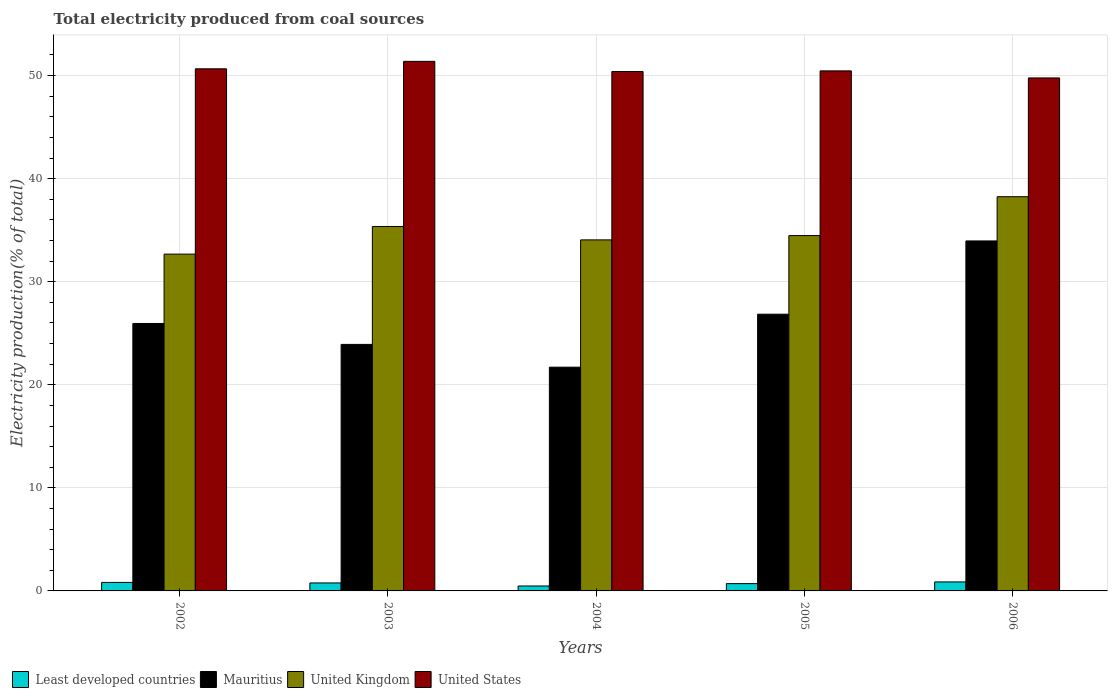How many groups of bars are there?
Give a very brief answer. 5. Are the number of bars per tick equal to the number of legend labels?
Ensure brevity in your answer.  Yes. How many bars are there on the 4th tick from the right?
Your answer should be very brief. 4. What is the total electricity produced in United States in 2003?
Your answer should be compact. 51.38. Across all years, what is the maximum total electricity produced in Mauritius?
Offer a very short reply. 33.96. Across all years, what is the minimum total electricity produced in Least developed countries?
Offer a very short reply. 0.48. In which year was the total electricity produced in Mauritius maximum?
Ensure brevity in your answer.  2006. What is the total total electricity produced in United States in the graph?
Your response must be concise. 252.67. What is the difference between the total electricity produced in United Kingdom in 2003 and that in 2004?
Give a very brief answer. 1.3. What is the difference between the total electricity produced in United Kingdom in 2005 and the total electricity produced in United States in 2006?
Ensure brevity in your answer.  -15.29. What is the average total electricity produced in Mauritius per year?
Give a very brief answer. 26.48. In the year 2002, what is the difference between the total electricity produced in United Kingdom and total electricity produced in Mauritius?
Ensure brevity in your answer.  6.73. In how many years, is the total electricity produced in Least developed countries greater than 28 %?
Ensure brevity in your answer.  0. What is the ratio of the total electricity produced in Mauritius in 2005 to that in 2006?
Give a very brief answer. 0.79. Is the total electricity produced in Least developed countries in 2004 less than that in 2006?
Provide a short and direct response. Yes. What is the difference between the highest and the second highest total electricity produced in United Kingdom?
Provide a short and direct response. 2.89. What is the difference between the highest and the lowest total electricity produced in United Kingdom?
Keep it short and to the point. 5.57. In how many years, is the total electricity produced in Mauritius greater than the average total electricity produced in Mauritius taken over all years?
Provide a succinct answer. 2. Is the sum of the total electricity produced in United States in 2002 and 2005 greater than the maximum total electricity produced in Least developed countries across all years?
Offer a very short reply. Yes. Is it the case that in every year, the sum of the total electricity produced in United States and total electricity produced in Mauritius is greater than the sum of total electricity produced in United Kingdom and total electricity produced in Least developed countries?
Your answer should be compact. Yes. What does the 2nd bar from the left in 2006 represents?
Your answer should be very brief. Mauritius. What does the 3rd bar from the right in 2002 represents?
Ensure brevity in your answer.  Mauritius. How many bars are there?
Your response must be concise. 20. Are all the bars in the graph horizontal?
Your answer should be very brief. No. Does the graph contain any zero values?
Your response must be concise. No. How are the legend labels stacked?
Provide a succinct answer. Horizontal. What is the title of the graph?
Provide a short and direct response. Total electricity produced from coal sources. What is the Electricity production(% of total) in Least developed countries in 2002?
Make the answer very short. 0.83. What is the Electricity production(% of total) in Mauritius in 2002?
Provide a succinct answer. 25.95. What is the Electricity production(% of total) of United Kingdom in 2002?
Your answer should be very brief. 32.68. What is the Electricity production(% of total) in United States in 2002?
Provide a succinct answer. 50.66. What is the Electricity production(% of total) in Least developed countries in 2003?
Ensure brevity in your answer.  0.77. What is the Electricity production(% of total) in Mauritius in 2003?
Ensure brevity in your answer.  23.92. What is the Electricity production(% of total) in United Kingdom in 2003?
Your answer should be very brief. 35.36. What is the Electricity production(% of total) in United States in 2003?
Keep it short and to the point. 51.38. What is the Electricity production(% of total) in Least developed countries in 2004?
Offer a terse response. 0.48. What is the Electricity production(% of total) in Mauritius in 2004?
Keep it short and to the point. 21.71. What is the Electricity production(% of total) of United Kingdom in 2004?
Make the answer very short. 34.06. What is the Electricity production(% of total) in United States in 2004?
Keep it short and to the point. 50.4. What is the Electricity production(% of total) in Least developed countries in 2005?
Offer a very short reply. 0.71. What is the Electricity production(% of total) of Mauritius in 2005?
Your response must be concise. 26.85. What is the Electricity production(% of total) in United Kingdom in 2005?
Give a very brief answer. 34.48. What is the Electricity production(% of total) in United States in 2005?
Make the answer very short. 50.46. What is the Electricity production(% of total) of Least developed countries in 2006?
Ensure brevity in your answer.  0.87. What is the Electricity production(% of total) of Mauritius in 2006?
Your response must be concise. 33.96. What is the Electricity production(% of total) of United Kingdom in 2006?
Your response must be concise. 38.25. What is the Electricity production(% of total) of United States in 2006?
Your response must be concise. 49.77. Across all years, what is the maximum Electricity production(% of total) in Least developed countries?
Give a very brief answer. 0.87. Across all years, what is the maximum Electricity production(% of total) of Mauritius?
Offer a terse response. 33.96. Across all years, what is the maximum Electricity production(% of total) in United Kingdom?
Keep it short and to the point. 38.25. Across all years, what is the maximum Electricity production(% of total) in United States?
Your response must be concise. 51.38. Across all years, what is the minimum Electricity production(% of total) in Least developed countries?
Your response must be concise. 0.48. Across all years, what is the minimum Electricity production(% of total) of Mauritius?
Provide a short and direct response. 21.71. Across all years, what is the minimum Electricity production(% of total) in United Kingdom?
Offer a very short reply. 32.68. Across all years, what is the minimum Electricity production(% of total) of United States?
Your answer should be compact. 49.77. What is the total Electricity production(% of total) in Least developed countries in the graph?
Offer a terse response. 3.66. What is the total Electricity production(% of total) of Mauritius in the graph?
Offer a terse response. 132.38. What is the total Electricity production(% of total) of United Kingdom in the graph?
Your response must be concise. 174.82. What is the total Electricity production(% of total) of United States in the graph?
Make the answer very short. 252.67. What is the difference between the Electricity production(% of total) in Least developed countries in 2002 and that in 2003?
Your answer should be compact. 0.05. What is the difference between the Electricity production(% of total) of Mauritius in 2002 and that in 2003?
Ensure brevity in your answer.  2.03. What is the difference between the Electricity production(% of total) in United Kingdom in 2002 and that in 2003?
Keep it short and to the point. -2.68. What is the difference between the Electricity production(% of total) in United States in 2002 and that in 2003?
Ensure brevity in your answer.  -0.72. What is the difference between the Electricity production(% of total) of Least developed countries in 2002 and that in 2004?
Keep it short and to the point. 0.35. What is the difference between the Electricity production(% of total) of Mauritius in 2002 and that in 2004?
Keep it short and to the point. 4.24. What is the difference between the Electricity production(% of total) of United Kingdom in 2002 and that in 2004?
Offer a very short reply. -1.38. What is the difference between the Electricity production(% of total) in United States in 2002 and that in 2004?
Ensure brevity in your answer.  0.26. What is the difference between the Electricity production(% of total) of Least developed countries in 2002 and that in 2005?
Your answer should be very brief. 0.12. What is the difference between the Electricity production(% of total) in Mauritius in 2002 and that in 2005?
Provide a short and direct response. -0.9. What is the difference between the Electricity production(% of total) in United Kingdom in 2002 and that in 2005?
Your answer should be compact. -1.8. What is the difference between the Electricity production(% of total) in United States in 2002 and that in 2005?
Give a very brief answer. 0.2. What is the difference between the Electricity production(% of total) in Least developed countries in 2002 and that in 2006?
Offer a very short reply. -0.05. What is the difference between the Electricity production(% of total) in Mauritius in 2002 and that in 2006?
Give a very brief answer. -8.01. What is the difference between the Electricity production(% of total) in United Kingdom in 2002 and that in 2006?
Your answer should be compact. -5.57. What is the difference between the Electricity production(% of total) of United States in 2002 and that in 2006?
Give a very brief answer. 0.88. What is the difference between the Electricity production(% of total) in Least developed countries in 2003 and that in 2004?
Offer a very short reply. 0.3. What is the difference between the Electricity production(% of total) in Mauritius in 2003 and that in 2004?
Provide a short and direct response. 2.21. What is the difference between the Electricity production(% of total) in United Kingdom in 2003 and that in 2004?
Provide a succinct answer. 1.3. What is the difference between the Electricity production(% of total) of United States in 2003 and that in 2004?
Provide a short and direct response. 0.98. What is the difference between the Electricity production(% of total) of Least developed countries in 2003 and that in 2005?
Give a very brief answer. 0.07. What is the difference between the Electricity production(% of total) of Mauritius in 2003 and that in 2005?
Make the answer very short. -2.93. What is the difference between the Electricity production(% of total) in United Kingdom in 2003 and that in 2005?
Provide a succinct answer. 0.88. What is the difference between the Electricity production(% of total) in United States in 2003 and that in 2005?
Your answer should be compact. 0.92. What is the difference between the Electricity production(% of total) of Least developed countries in 2003 and that in 2006?
Your answer should be very brief. -0.1. What is the difference between the Electricity production(% of total) of Mauritius in 2003 and that in 2006?
Provide a short and direct response. -10.04. What is the difference between the Electricity production(% of total) in United Kingdom in 2003 and that in 2006?
Ensure brevity in your answer.  -2.89. What is the difference between the Electricity production(% of total) in United States in 2003 and that in 2006?
Offer a very short reply. 1.61. What is the difference between the Electricity production(% of total) of Least developed countries in 2004 and that in 2005?
Make the answer very short. -0.23. What is the difference between the Electricity production(% of total) in Mauritius in 2004 and that in 2005?
Keep it short and to the point. -5.14. What is the difference between the Electricity production(% of total) of United Kingdom in 2004 and that in 2005?
Ensure brevity in your answer.  -0.42. What is the difference between the Electricity production(% of total) of United States in 2004 and that in 2005?
Your answer should be compact. -0.06. What is the difference between the Electricity production(% of total) in Least developed countries in 2004 and that in 2006?
Your answer should be very brief. -0.39. What is the difference between the Electricity production(% of total) in Mauritius in 2004 and that in 2006?
Make the answer very short. -12.25. What is the difference between the Electricity production(% of total) of United Kingdom in 2004 and that in 2006?
Offer a very short reply. -4.19. What is the difference between the Electricity production(% of total) of United States in 2004 and that in 2006?
Provide a short and direct response. 0.62. What is the difference between the Electricity production(% of total) in Least developed countries in 2005 and that in 2006?
Offer a terse response. -0.16. What is the difference between the Electricity production(% of total) of Mauritius in 2005 and that in 2006?
Provide a short and direct response. -7.11. What is the difference between the Electricity production(% of total) of United Kingdom in 2005 and that in 2006?
Offer a terse response. -3.77. What is the difference between the Electricity production(% of total) of United States in 2005 and that in 2006?
Give a very brief answer. 0.68. What is the difference between the Electricity production(% of total) in Least developed countries in 2002 and the Electricity production(% of total) in Mauritius in 2003?
Give a very brief answer. -23.09. What is the difference between the Electricity production(% of total) of Least developed countries in 2002 and the Electricity production(% of total) of United Kingdom in 2003?
Offer a terse response. -34.53. What is the difference between the Electricity production(% of total) in Least developed countries in 2002 and the Electricity production(% of total) in United States in 2003?
Keep it short and to the point. -50.56. What is the difference between the Electricity production(% of total) of Mauritius in 2002 and the Electricity production(% of total) of United Kingdom in 2003?
Your answer should be compact. -9.41. What is the difference between the Electricity production(% of total) of Mauritius in 2002 and the Electricity production(% of total) of United States in 2003?
Offer a very short reply. -25.43. What is the difference between the Electricity production(% of total) of United Kingdom in 2002 and the Electricity production(% of total) of United States in 2003?
Make the answer very short. -18.7. What is the difference between the Electricity production(% of total) of Least developed countries in 2002 and the Electricity production(% of total) of Mauritius in 2004?
Ensure brevity in your answer.  -20.88. What is the difference between the Electricity production(% of total) of Least developed countries in 2002 and the Electricity production(% of total) of United Kingdom in 2004?
Provide a succinct answer. -33.23. What is the difference between the Electricity production(% of total) of Least developed countries in 2002 and the Electricity production(% of total) of United States in 2004?
Offer a terse response. -49.57. What is the difference between the Electricity production(% of total) in Mauritius in 2002 and the Electricity production(% of total) in United Kingdom in 2004?
Offer a very short reply. -8.11. What is the difference between the Electricity production(% of total) of Mauritius in 2002 and the Electricity production(% of total) of United States in 2004?
Make the answer very short. -24.45. What is the difference between the Electricity production(% of total) in United Kingdom in 2002 and the Electricity production(% of total) in United States in 2004?
Offer a terse response. -17.72. What is the difference between the Electricity production(% of total) in Least developed countries in 2002 and the Electricity production(% of total) in Mauritius in 2005?
Your answer should be very brief. -26.02. What is the difference between the Electricity production(% of total) in Least developed countries in 2002 and the Electricity production(% of total) in United Kingdom in 2005?
Your response must be concise. -33.65. What is the difference between the Electricity production(% of total) in Least developed countries in 2002 and the Electricity production(% of total) in United States in 2005?
Ensure brevity in your answer.  -49.63. What is the difference between the Electricity production(% of total) of Mauritius in 2002 and the Electricity production(% of total) of United Kingdom in 2005?
Offer a very short reply. -8.53. What is the difference between the Electricity production(% of total) in Mauritius in 2002 and the Electricity production(% of total) in United States in 2005?
Make the answer very short. -24.51. What is the difference between the Electricity production(% of total) in United Kingdom in 2002 and the Electricity production(% of total) in United States in 2005?
Ensure brevity in your answer.  -17.78. What is the difference between the Electricity production(% of total) in Least developed countries in 2002 and the Electricity production(% of total) in Mauritius in 2006?
Offer a very short reply. -33.13. What is the difference between the Electricity production(% of total) of Least developed countries in 2002 and the Electricity production(% of total) of United Kingdom in 2006?
Give a very brief answer. -37.42. What is the difference between the Electricity production(% of total) of Least developed countries in 2002 and the Electricity production(% of total) of United States in 2006?
Offer a terse response. -48.95. What is the difference between the Electricity production(% of total) of Mauritius in 2002 and the Electricity production(% of total) of United Kingdom in 2006?
Make the answer very short. -12.3. What is the difference between the Electricity production(% of total) of Mauritius in 2002 and the Electricity production(% of total) of United States in 2006?
Your answer should be compact. -23.82. What is the difference between the Electricity production(% of total) of United Kingdom in 2002 and the Electricity production(% of total) of United States in 2006?
Give a very brief answer. -17.09. What is the difference between the Electricity production(% of total) in Least developed countries in 2003 and the Electricity production(% of total) in Mauritius in 2004?
Your response must be concise. -20.94. What is the difference between the Electricity production(% of total) of Least developed countries in 2003 and the Electricity production(% of total) of United Kingdom in 2004?
Give a very brief answer. -33.29. What is the difference between the Electricity production(% of total) of Least developed countries in 2003 and the Electricity production(% of total) of United States in 2004?
Keep it short and to the point. -49.62. What is the difference between the Electricity production(% of total) of Mauritius in 2003 and the Electricity production(% of total) of United Kingdom in 2004?
Provide a succinct answer. -10.14. What is the difference between the Electricity production(% of total) in Mauritius in 2003 and the Electricity production(% of total) in United States in 2004?
Keep it short and to the point. -26.48. What is the difference between the Electricity production(% of total) of United Kingdom in 2003 and the Electricity production(% of total) of United States in 2004?
Your answer should be compact. -15.04. What is the difference between the Electricity production(% of total) in Least developed countries in 2003 and the Electricity production(% of total) in Mauritius in 2005?
Offer a terse response. -26.08. What is the difference between the Electricity production(% of total) of Least developed countries in 2003 and the Electricity production(% of total) of United Kingdom in 2005?
Offer a very short reply. -33.7. What is the difference between the Electricity production(% of total) of Least developed countries in 2003 and the Electricity production(% of total) of United States in 2005?
Provide a succinct answer. -49.68. What is the difference between the Electricity production(% of total) of Mauritius in 2003 and the Electricity production(% of total) of United Kingdom in 2005?
Your answer should be compact. -10.56. What is the difference between the Electricity production(% of total) in Mauritius in 2003 and the Electricity production(% of total) in United States in 2005?
Your answer should be very brief. -26.54. What is the difference between the Electricity production(% of total) of United Kingdom in 2003 and the Electricity production(% of total) of United States in 2005?
Give a very brief answer. -15.1. What is the difference between the Electricity production(% of total) in Least developed countries in 2003 and the Electricity production(% of total) in Mauritius in 2006?
Offer a very short reply. -33.18. What is the difference between the Electricity production(% of total) of Least developed countries in 2003 and the Electricity production(% of total) of United Kingdom in 2006?
Your answer should be compact. -37.47. What is the difference between the Electricity production(% of total) of Least developed countries in 2003 and the Electricity production(% of total) of United States in 2006?
Provide a short and direct response. -49. What is the difference between the Electricity production(% of total) of Mauritius in 2003 and the Electricity production(% of total) of United Kingdom in 2006?
Offer a terse response. -14.33. What is the difference between the Electricity production(% of total) in Mauritius in 2003 and the Electricity production(% of total) in United States in 2006?
Offer a very short reply. -25.85. What is the difference between the Electricity production(% of total) of United Kingdom in 2003 and the Electricity production(% of total) of United States in 2006?
Provide a short and direct response. -14.41. What is the difference between the Electricity production(% of total) of Least developed countries in 2004 and the Electricity production(% of total) of Mauritius in 2005?
Ensure brevity in your answer.  -26.37. What is the difference between the Electricity production(% of total) of Least developed countries in 2004 and the Electricity production(% of total) of United Kingdom in 2005?
Offer a very short reply. -34. What is the difference between the Electricity production(% of total) of Least developed countries in 2004 and the Electricity production(% of total) of United States in 2005?
Offer a terse response. -49.98. What is the difference between the Electricity production(% of total) in Mauritius in 2004 and the Electricity production(% of total) in United Kingdom in 2005?
Your answer should be very brief. -12.77. What is the difference between the Electricity production(% of total) in Mauritius in 2004 and the Electricity production(% of total) in United States in 2005?
Your answer should be compact. -28.75. What is the difference between the Electricity production(% of total) of United Kingdom in 2004 and the Electricity production(% of total) of United States in 2005?
Keep it short and to the point. -16.4. What is the difference between the Electricity production(% of total) in Least developed countries in 2004 and the Electricity production(% of total) in Mauritius in 2006?
Your answer should be very brief. -33.48. What is the difference between the Electricity production(% of total) of Least developed countries in 2004 and the Electricity production(% of total) of United Kingdom in 2006?
Provide a short and direct response. -37.77. What is the difference between the Electricity production(% of total) in Least developed countries in 2004 and the Electricity production(% of total) in United States in 2006?
Offer a terse response. -49.3. What is the difference between the Electricity production(% of total) in Mauritius in 2004 and the Electricity production(% of total) in United Kingdom in 2006?
Provide a short and direct response. -16.54. What is the difference between the Electricity production(% of total) of Mauritius in 2004 and the Electricity production(% of total) of United States in 2006?
Give a very brief answer. -28.06. What is the difference between the Electricity production(% of total) of United Kingdom in 2004 and the Electricity production(% of total) of United States in 2006?
Keep it short and to the point. -15.71. What is the difference between the Electricity production(% of total) of Least developed countries in 2005 and the Electricity production(% of total) of Mauritius in 2006?
Your answer should be very brief. -33.25. What is the difference between the Electricity production(% of total) of Least developed countries in 2005 and the Electricity production(% of total) of United Kingdom in 2006?
Offer a terse response. -37.54. What is the difference between the Electricity production(% of total) in Least developed countries in 2005 and the Electricity production(% of total) in United States in 2006?
Your answer should be compact. -49.07. What is the difference between the Electricity production(% of total) of Mauritius in 2005 and the Electricity production(% of total) of United Kingdom in 2006?
Keep it short and to the point. -11.4. What is the difference between the Electricity production(% of total) of Mauritius in 2005 and the Electricity production(% of total) of United States in 2006?
Ensure brevity in your answer.  -22.92. What is the difference between the Electricity production(% of total) in United Kingdom in 2005 and the Electricity production(% of total) in United States in 2006?
Provide a short and direct response. -15.29. What is the average Electricity production(% of total) of Least developed countries per year?
Provide a short and direct response. 0.73. What is the average Electricity production(% of total) in Mauritius per year?
Offer a terse response. 26.48. What is the average Electricity production(% of total) of United Kingdom per year?
Give a very brief answer. 34.97. What is the average Electricity production(% of total) of United States per year?
Provide a short and direct response. 50.53. In the year 2002, what is the difference between the Electricity production(% of total) of Least developed countries and Electricity production(% of total) of Mauritius?
Provide a short and direct response. -25.12. In the year 2002, what is the difference between the Electricity production(% of total) of Least developed countries and Electricity production(% of total) of United Kingdom?
Provide a succinct answer. -31.85. In the year 2002, what is the difference between the Electricity production(% of total) of Least developed countries and Electricity production(% of total) of United States?
Offer a terse response. -49.83. In the year 2002, what is the difference between the Electricity production(% of total) of Mauritius and Electricity production(% of total) of United Kingdom?
Your answer should be very brief. -6.73. In the year 2002, what is the difference between the Electricity production(% of total) of Mauritius and Electricity production(% of total) of United States?
Provide a succinct answer. -24.71. In the year 2002, what is the difference between the Electricity production(% of total) in United Kingdom and Electricity production(% of total) in United States?
Give a very brief answer. -17.98. In the year 2003, what is the difference between the Electricity production(% of total) in Least developed countries and Electricity production(% of total) in Mauritius?
Offer a terse response. -23.15. In the year 2003, what is the difference between the Electricity production(% of total) in Least developed countries and Electricity production(% of total) in United Kingdom?
Make the answer very short. -34.59. In the year 2003, what is the difference between the Electricity production(% of total) of Least developed countries and Electricity production(% of total) of United States?
Your response must be concise. -50.61. In the year 2003, what is the difference between the Electricity production(% of total) in Mauritius and Electricity production(% of total) in United Kingdom?
Provide a short and direct response. -11.44. In the year 2003, what is the difference between the Electricity production(% of total) of Mauritius and Electricity production(% of total) of United States?
Offer a very short reply. -27.46. In the year 2003, what is the difference between the Electricity production(% of total) of United Kingdom and Electricity production(% of total) of United States?
Give a very brief answer. -16.02. In the year 2004, what is the difference between the Electricity production(% of total) of Least developed countries and Electricity production(% of total) of Mauritius?
Your response must be concise. -21.23. In the year 2004, what is the difference between the Electricity production(% of total) of Least developed countries and Electricity production(% of total) of United Kingdom?
Your response must be concise. -33.58. In the year 2004, what is the difference between the Electricity production(% of total) in Least developed countries and Electricity production(% of total) in United States?
Give a very brief answer. -49.92. In the year 2004, what is the difference between the Electricity production(% of total) in Mauritius and Electricity production(% of total) in United Kingdom?
Make the answer very short. -12.35. In the year 2004, what is the difference between the Electricity production(% of total) in Mauritius and Electricity production(% of total) in United States?
Provide a short and direct response. -28.69. In the year 2004, what is the difference between the Electricity production(% of total) in United Kingdom and Electricity production(% of total) in United States?
Give a very brief answer. -16.34. In the year 2005, what is the difference between the Electricity production(% of total) in Least developed countries and Electricity production(% of total) in Mauritius?
Your answer should be very brief. -26.14. In the year 2005, what is the difference between the Electricity production(% of total) in Least developed countries and Electricity production(% of total) in United Kingdom?
Offer a very short reply. -33.77. In the year 2005, what is the difference between the Electricity production(% of total) in Least developed countries and Electricity production(% of total) in United States?
Ensure brevity in your answer.  -49.75. In the year 2005, what is the difference between the Electricity production(% of total) in Mauritius and Electricity production(% of total) in United Kingdom?
Offer a very short reply. -7.63. In the year 2005, what is the difference between the Electricity production(% of total) of Mauritius and Electricity production(% of total) of United States?
Your response must be concise. -23.61. In the year 2005, what is the difference between the Electricity production(% of total) of United Kingdom and Electricity production(% of total) of United States?
Ensure brevity in your answer.  -15.98. In the year 2006, what is the difference between the Electricity production(% of total) in Least developed countries and Electricity production(% of total) in Mauritius?
Offer a terse response. -33.09. In the year 2006, what is the difference between the Electricity production(% of total) of Least developed countries and Electricity production(% of total) of United Kingdom?
Offer a terse response. -37.38. In the year 2006, what is the difference between the Electricity production(% of total) in Least developed countries and Electricity production(% of total) in United States?
Your answer should be very brief. -48.9. In the year 2006, what is the difference between the Electricity production(% of total) of Mauritius and Electricity production(% of total) of United Kingdom?
Make the answer very short. -4.29. In the year 2006, what is the difference between the Electricity production(% of total) of Mauritius and Electricity production(% of total) of United States?
Offer a very short reply. -15.82. In the year 2006, what is the difference between the Electricity production(% of total) in United Kingdom and Electricity production(% of total) in United States?
Offer a very short reply. -11.52. What is the ratio of the Electricity production(% of total) in Least developed countries in 2002 to that in 2003?
Offer a very short reply. 1.07. What is the ratio of the Electricity production(% of total) in Mauritius in 2002 to that in 2003?
Offer a very short reply. 1.08. What is the ratio of the Electricity production(% of total) of United Kingdom in 2002 to that in 2003?
Offer a very short reply. 0.92. What is the ratio of the Electricity production(% of total) in United States in 2002 to that in 2003?
Provide a succinct answer. 0.99. What is the ratio of the Electricity production(% of total) of Least developed countries in 2002 to that in 2004?
Provide a short and direct response. 1.73. What is the ratio of the Electricity production(% of total) of Mauritius in 2002 to that in 2004?
Your response must be concise. 1.2. What is the ratio of the Electricity production(% of total) in United Kingdom in 2002 to that in 2004?
Give a very brief answer. 0.96. What is the ratio of the Electricity production(% of total) of United States in 2002 to that in 2004?
Offer a very short reply. 1.01. What is the ratio of the Electricity production(% of total) of Least developed countries in 2002 to that in 2005?
Offer a very short reply. 1.17. What is the ratio of the Electricity production(% of total) in Mauritius in 2002 to that in 2005?
Your answer should be compact. 0.97. What is the ratio of the Electricity production(% of total) in United Kingdom in 2002 to that in 2005?
Keep it short and to the point. 0.95. What is the ratio of the Electricity production(% of total) in United States in 2002 to that in 2005?
Your answer should be very brief. 1. What is the ratio of the Electricity production(% of total) in Least developed countries in 2002 to that in 2006?
Offer a terse response. 0.95. What is the ratio of the Electricity production(% of total) of Mauritius in 2002 to that in 2006?
Ensure brevity in your answer.  0.76. What is the ratio of the Electricity production(% of total) of United Kingdom in 2002 to that in 2006?
Give a very brief answer. 0.85. What is the ratio of the Electricity production(% of total) in United States in 2002 to that in 2006?
Make the answer very short. 1.02. What is the ratio of the Electricity production(% of total) of Least developed countries in 2003 to that in 2004?
Offer a terse response. 1.62. What is the ratio of the Electricity production(% of total) of Mauritius in 2003 to that in 2004?
Provide a succinct answer. 1.1. What is the ratio of the Electricity production(% of total) in United Kingdom in 2003 to that in 2004?
Your answer should be compact. 1.04. What is the ratio of the Electricity production(% of total) of United States in 2003 to that in 2004?
Offer a terse response. 1.02. What is the ratio of the Electricity production(% of total) of Least developed countries in 2003 to that in 2005?
Your answer should be very brief. 1.09. What is the ratio of the Electricity production(% of total) of Mauritius in 2003 to that in 2005?
Give a very brief answer. 0.89. What is the ratio of the Electricity production(% of total) in United Kingdom in 2003 to that in 2005?
Keep it short and to the point. 1.03. What is the ratio of the Electricity production(% of total) in United States in 2003 to that in 2005?
Ensure brevity in your answer.  1.02. What is the ratio of the Electricity production(% of total) in Least developed countries in 2003 to that in 2006?
Offer a terse response. 0.89. What is the ratio of the Electricity production(% of total) of Mauritius in 2003 to that in 2006?
Your response must be concise. 0.7. What is the ratio of the Electricity production(% of total) in United Kingdom in 2003 to that in 2006?
Ensure brevity in your answer.  0.92. What is the ratio of the Electricity production(% of total) of United States in 2003 to that in 2006?
Make the answer very short. 1.03. What is the ratio of the Electricity production(% of total) in Least developed countries in 2004 to that in 2005?
Offer a very short reply. 0.68. What is the ratio of the Electricity production(% of total) in Mauritius in 2004 to that in 2005?
Make the answer very short. 0.81. What is the ratio of the Electricity production(% of total) in Least developed countries in 2004 to that in 2006?
Offer a terse response. 0.55. What is the ratio of the Electricity production(% of total) in Mauritius in 2004 to that in 2006?
Keep it short and to the point. 0.64. What is the ratio of the Electricity production(% of total) in United Kingdom in 2004 to that in 2006?
Make the answer very short. 0.89. What is the ratio of the Electricity production(% of total) in United States in 2004 to that in 2006?
Offer a terse response. 1.01. What is the ratio of the Electricity production(% of total) of Least developed countries in 2005 to that in 2006?
Your response must be concise. 0.81. What is the ratio of the Electricity production(% of total) in Mauritius in 2005 to that in 2006?
Keep it short and to the point. 0.79. What is the ratio of the Electricity production(% of total) in United Kingdom in 2005 to that in 2006?
Give a very brief answer. 0.9. What is the ratio of the Electricity production(% of total) of United States in 2005 to that in 2006?
Your response must be concise. 1.01. What is the difference between the highest and the second highest Electricity production(% of total) of Least developed countries?
Your answer should be compact. 0.05. What is the difference between the highest and the second highest Electricity production(% of total) of Mauritius?
Ensure brevity in your answer.  7.11. What is the difference between the highest and the second highest Electricity production(% of total) of United Kingdom?
Your answer should be compact. 2.89. What is the difference between the highest and the second highest Electricity production(% of total) of United States?
Ensure brevity in your answer.  0.72. What is the difference between the highest and the lowest Electricity production(% of total) in Least developed countries?
Give a very brief answer. 0.39. What is the difference between the highest and the lowest Electricity production(% of total) in Mauritius?
Offer a terse response. 12.25. What is the difference between the highest and the lowest Electricity production(% of total) in United Kingdom?
Your response must be concise. 5.57. What is the difference between the highest and the lowest Electricity production(% of total) of United States?
Your answer should be compact. 1.61. 